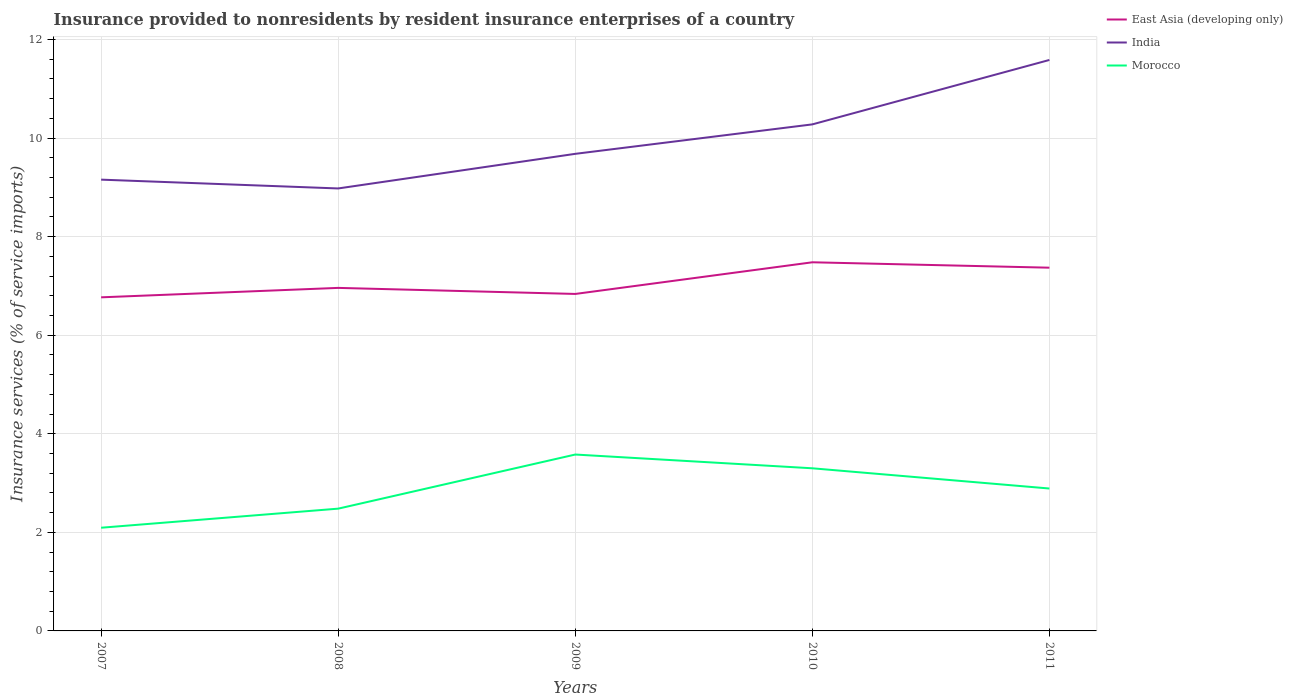Does the line corresponding to India intersect with the line corresponding to East Asia (developing only)?
Make the answer very short. No. Is the number of lines equal to the number of legend labels?
Provide a short and direct response. Yes. Across all years, what is the maximum insurance provided to nonresidents in India?
Give a very brief answer. 8.98. What is the total insurance provided to nonresidents in India in the graph?
Ensure brevity in your answer.  -1.3. What is the difference between the highest and the second highest insurance provided to nonresidents in East Asia (developing only)?
Your answer should be compact. 0.71. How many lines are there?
Provide a short and direct response. 3. What is the difference between two consecutive major ticks on the Y-axis?
Provide a succinct answer. 2. Does the graph contain any zero values?
Offer a terse response. No. Does the graph contain grids?
Make the answer very short. Yes. Where does the legend appear in the graph?
Ensure brevity in your answer.  Top right. How many legend labels are there?
Provide a succinct answer. 3. What is the title of the graph?
Make the answer very short. Insurance provided to nonresidents by resident insurance enterprises of a country. What is the label or title of the Y-axis?
Ensure brevity in your answer.  Insurance services (% of service imports). What is the Insurance services (% of service imports) of East Asia (developing only) in 2007?
Offer a very short reply. 6.77. What is the Insurance services (% of service imports) of India in 2007?
Make the answer very short. 9.16. What is the Insurance services (% of service imports) in Morocco in 2007?
Your response must be concise. 2.09. What is the Insurance services (% of service imports) in East Asia (developing only) in 2008?
Keep it short and to the point. 6.96. What is the Insurance services (% of service imports) in India in 2008?
Ensure brevity in your answer.  8.98. What is the Insurance services (% of service imports) of Morocco in 2008?
Offer a terse response. 2.48. What is the Insurance services (% of service imports) of East Asia (developing only) in 2009?
Provide a short and direct response. 6.84. What is the Insurance services (% of service imports) in India in 2009?
Offer a very short reply. 9.68. What is the Insurance services (% of service imports) of Morocco in 2009?
Keep it short and to the point. 3.58. What is the Insurance services (% of service imports) of East Asia (developing only) in 2010?
Keep it short and to the point. 7.48. What is the Insurance services (% of service imports) of India in 2010?
Provide a short and direct response. 10.28. What is the Insurance services (% of service imports) of Morocco in 2010?
Offer a terse response. 3.3. What is the Insurance services (% of service imports) of East Asia (developing only) in 2011?
Offer a terse response. 7.37. What is the Insurance services (% of service imports) in India in 2011?
Ensure brevity in your answer.  11.59. What is the Insurance services (% of service imports) of Morocco in 2011?
Your response must be concise. 2.89. Across all years, what is the maximum Insurance services (% of service imports) in East Asia (developing only)?
Offer a terse response. 7.48. Across all years, what is the maximum Insurance services (% of service imports) in India?
Offer a terse response. 11.59. Across all years, what is the maximum Insurance services (% of service imports) of Morocco?
Your response must be concise. 3.58. Across all years, what is the minimum Insurance services (% of service imports) of East Asia (developing only)?
Offer a terse response. 6.77. Across all years, what is the minimum Insurance services (% of service imports) of India?
Keep it short and to the point. 8.98. Across all years, what is the minimum Insurance services (% of service imports) of Morocco?
Ensure brevity in your answer.  2.09. What is the total Insurance services (% of service imports) in East Asia (developing only) in the graph?
Make the answer very short. 35.42. What is the total Insurance services (% of service imports) in India in the graph?
Your response must be concise. 49.68. What is the total Insurance services (% of service imports) in Morocco in the graph?
Provide a succinct answer. 14.34. What is the difference between the Insurance services (% of service imports) of East Asia (developing only) in 2007 and that in 2008?
Offer a very short reply. -0.19. What is the difference between the Insurance services (% of service imports) in India in 2007 and that in 2008?
Your answer should be very brief. 0.18. What is the difference between the Insurance services (% of service imports) of Morocco in 2007 and that in 2008?
Your answer should be compact. -0.39. What is the difference between the Insurance services (% of service imports) in East Asia (developing only) in 2007 and that in 2009?
Make the answer very short. -0.07. What is the difference between the Insurance services (% of service imports) of India in 2007 and that in 2009?
Provide a succinct answer. -0.52. What is the difference between the Insurance services (% of service imports) in Morocco in 2007 and that in 2009?
Your answer should be very brief. -1.49. What is the difference between the Insurance services (% of service imports) in East Asia (developing only) in 2007 and that in 2010?
Keep it short and to the point. -0.71. What is the difference between the Insurance services (% of service imports) in India in 2007 and that in 2010?
Your answer should be compact. -1.12. What is the difference between the Insurance services (% of service imports) of Morocco in 2007 and that in 2010?
Provide a short and direct response. -1.21. What is the difference between the Insurance services (% of service imports) in East Asia (developing only) in 2007 and that in 2011?
Ensure brevity in your answer.  -0.6. What is the difference between the Insurance services (% of service imports) in India in 2007 and that in 2011?
Offer a very short reply. -2.43. What is the difference between the Insurance services (% of service imports) of Morocco in 2007 and that in 2011?
Offer a terse response. -0.8. What is the difference between the Insurance services (% of service imports) in East Asia (developing only) in 2008 and that in 2009?
Ensure brevity in your answer.  0.12. What is the difference between the Insurance services (% of service imports) of India in 2008 and that in 2009?
Make the answer very short. -0.7. What is the difference between the Insurance services (% of service imports) of Morocco in 2008 and that in 2009?
Ensure brevity in your answer.  -1.1. What is the difference between the Insurance services (% of service imports) of East Asia (developing only) in 2008 and that in 2010?
Your response must be concise. -0.52. What is the difference between the Insurance services (% of service imports) in Morocco in 2008 and that in 2010?
Keep it short and to the point. -0.82. What is the difference between the Insurance services (% of service imports) of East Asia (developing only) in 2008 and that in 2011?
Provide a succinct answer. -0.41. What is the difference between the Insurance services (% of service imports) in India in 2008 and that in 2011?
Ensure brevity in your answer.  -2.61. What is the difference between the Insurance services (% of service imports) in Morocco in 2008 and that in 2011?
Your answer should be compact. -0.41. What is the difference between the Insurance services (% of service imports) in East Asia (developing only) in 2009 and that in 2010?
Make the answer very short. -0.64. What is the difference between the Insurance services (% of service imports) of India in 2009 and that in 2010?
Your answer should be compact. -0.6. What is the difference between the Insurance services (% of service imports) in Morocco in 2009 and that in 2010?
Your answer should be compact. 0.28. What is the difference between the Insurance services (% of service imports) in East Asia (developing only) in 2009 and that in 2011?
Offer a very short reply. -0.53. What is the difference between the Insurance services (% of service imports) in India in 2009 and that in 2011?
Ensure brevity in your answer.  -1.9. What is the difference between the Insurance services (% of service imports) in Morocco in 2009 and that in 2011?
Your answer should be compact. 0.69. What is the difference between the Insurance services (% of service imports) in East Asia (developing only) in 2010 and that in 2011?
Your answer should be very brief. 0.11. What is the difference between the Insurance services (% of service imports) of India in 2010 and that in 2011?
Your answer should be very brief. -1.31. What is the difference between the Insurance services (% of service imports) in Morocco in 2010 and that in 2011?
Provide a short and direct response. 0.41. What is the difference between the Insurance services (% of service imports) of East Asia (developing only) in 2007 and the Insurance services (% of service imports) of India in 2008?
Make the answer very short. -2.21. What is the difference between the Insurance services (% of service imports) in East Asia (developing only) in 2007 and the Insurance services (% of service imports) in Morocco in 2008?
Offer a very short reply. 4.29. What is the difference between the Insurance services (% of service imports) of India in 2007 and the Insurance services (% of service imports) of Morocco in 2008?
Give a very brief answer. 6.68. What is the difference between the Insurance services (% of service imports) in East Asia (developing only) in 2007 and the Insurance services (% of service imports) in India in 2009?
Offer a very short reply. -2.91. What is the difference between the Insurance services (% of service imports) of East Asia (developing only) in 2007 and the Insurance services (% of service imports) of Morocco in 2009?
Provide a short and direct response. 3.19. What is the difference between the Insurance services (% of service imports) in India in 2007 and the Insurance services (% of service imports) in Morocco in 2009?
Make the answer very short. 5.58. What is the difference between the Insurance services (% of service imports) of East Asia (developing only) in 2007 and the Insurance services (% of service imports) of India in 2010?
Keep it short and to the point. -3.51. What is the difference between the Insurance services (% of service imports) in East Asia (developing only) in 2007 and the Insurance services (% of service imports) in Morocco in 2010?
Give a very brief answer. 3.47. What is the difference between the Insurance services (% of service imports) of India in 2007 and the Insurance services (% of service imports) of Morocco in 2010?
Offer a very short reply. 5.86. What is the difference between the Insurance services (% of service imports) in East Asia (developing only) in 2007 and the Insurance services (% of service imports) in India in 2011?
Offer a very short reply. -4.82. What is the difference between the Insurance services (% of service imports) of East Asia (developing only) in 2007 and the Insurance services (% of service imports) of Morocco in 2011?
Offer a terse response. 3.88. What is the difference between the Insurance services (% of service imports) in India in 2007 and the Insurance services (% of service imports) in Morocco in 2011?
Offer a terse response. 6.27. What is the difference between the Insurance services (% of service imports) in East Asia (developing only) in 2008 and the Insurance services (% of service imports) in India in 2009?
Ensure brevity in your answer.  -2.72. What is the difference between the Insurance services (% of service imports) in East Asia (developing only) in 2008 and the Insurance services (% of service imports) in Morocco in 2009?
Provide a succinct answer. 3.38. What is the difference between the Insurance services (% of service imports) in India in 2008 and the Insurance services (% of service imports) in Morocco in 2009?
Offer a very short reply. 5.4. What is the difference between the Insurance services (% of service imports) of East Asia (developing only) in 2008 and the Insurance services (% of service imports) of India in 2010?
Offer a terse response. -3.32. What is the difference between the Insurance services (% of service imports) of East Asia (developing only) in 2008 and the Insurance services (% of service imports) of Morocco in 2010?
Offer a very short reply. 3.66. What is the difference between the Insurance services (% of service imports) in India in 2008 and the Insurance services (% of service imports) in Morocco in 2010?
Ensure brevity in your answer.  5.68. What is the difference between the Insurance services (% of service imports) in East Asia (developing only) in 2008 and the Insurance services (% of service imports) in India in 2011?
Offer a very short reply. -4.62. What is the difference between the Insurance services (% of service imports) of East Asia (developing only) in 2008 and the Insurance services (% of service imports) of Morocco in 2011?
Provide a short and direct response. 4.07. What is the difference between the Insurance services (% of service imports) of India in 2008 and the Insurance services (% of service imports) of Morocco in 2011?
Your answer should be very brief. 6.09. What is the difference between the Insurance services (% of service imports) in East Asia (developing only) in 2009 and the Insurance services (% of service imports) in India in 2010?
Your answer should be compact. -3.44. What is the difference between the Insurance services (% of service imports) in East Asia (developing only) in 2009 and the Insurance services (% of service imports) in Morocco in 2010?
Your response must be concise. 3.54. What is the difference between the Insurance services (% of service imports) of India in 2009 and the Insurance services (% of service imports) of Morocco in 2010?
Your answer should be very brief. 6.38. What is the difference between the Insurance services (% of service imports) in East Asia (developing only) in 2009 and the Insurance services (% of service imports) in India in 2011?
Your answer should be very brief. -4.75. What is the difference between the Insurance services (% of service imports) of East Asia (developing only) in 2009 and the Insurance services (% of service imports) of Morocco in 2011?
Keep it short and to the point. 3.95. What is the difference between the Insurance services (% of service imports) of India in 2009 and the Insurance services (% of service imports) of Morocco in 2011?
Provide a short and direct response. 6.79. What is the difference between the Insurance services (% of service imports) in East Asia (developing only) in 2010 and the Insurance services (% of service imports) in India in 2011?
Offer a terse response. -4.11. What is the difference between the Insurance services (% of service imports) of East Asia (developing only) in 2010 and the Insurance services (% of service imports) of Morocco in 2011?
Your response must be concise. 4.59. What is the difference between the Insurance services (% of service imports) of India in 2010 and the Insurance services (% of service imports) of Morocco in 2011?
Offer a terse response. 7.39. What is the average Insurance services (% of service imports) in East Asia (developing only) per year?
Make the answer very short. 7.08. What is the average Insurance services (% of service imports) of India per year?
Offer a very short reply. 9.94. What is the average Insurance services (% of service imports) of Morocco per year?
Your answer should be very brief. 2.87. In the year 2007, what is the difference between the Insurance services (% of service imports) in East Asia (developing only) and Insurance services (% of service imports) in India?
Offer a very short reply. -2.39. In the year 2007, what is the difference between the Insurance services (% of service imports) in East Asia (developing only) and Insurance services (% of service imports) in Morocco?
Your answer should be very brief. 4.67. In the year 2007, what is the difference between the Insurance services (% of service imports) in India and Insurance services (% of service imports) in Morocco?
Give a very brief answer. 7.06. In the year 2008, what is the difference between the Insurance services (% of service imports) of East Asia (developing only) and Insurance services (% of service imports) of India?
Make the answer very short. -2.02. In the year 2008, what is the difference between the Insurance services (% of service imports) in East Asia (developing only) and Insurance services (% of service imports) in Morocco?
Provide a succinct answer. 4.48. In the year 2008, what is the difference between the Insurance services (% of service imports) of India and Insurance services (% of service imports) of Morocco?
Ensure brevity in your answer.  6.5. In the year 2009, what is the difference between the Insurance services (% of service imports) of East Asia (developing only) and Insurance services (% of service imports) of India?
Provide a succinct answer. -2.84. In the year 2009, what is the difference between the Insurance services (% of service imports) in East Asia (developing only) and Insurance services (% of service imports) in Morocco?
Provide a succinct answer. 3.26. In the year 2009, what is the difference between the Insurance services (% of service imports) of India and Insurance services (% of service imports) of Morocco?
Your answer should be compact. 6.1. In the year 2010, what is the difference between the Insurance services (% of service imports) in East Asia (developing only) and Insurance services (% of service imports) in India?
Your answer should be compact. -2.8. In the year 2010, what is the difference between the Insurance services (% of service imports) of East Asia (developing only) and Insurance services (% of service imports) of Morocco?
Offer a very short reply. 4.18. In the year 2010, what is the difference between the Insurance services (% of service imports) in India and Insurance services (% of service imports) in Morocco?
Offer a terse response. 6.98. In the year 2011, what is the difference between the Insurance services (% of service imports) of East Asia (developing only) and Insurance services (% of service imports) of India?
Keep it short and to the point. -4.21. In the year 2011, what is the difference between the Insurance services (% of service imports) in East Asia (developing only) and Insurance services (% of service imports) in Morocco?
Your answer should be very brief. 4.48. In the year 2011, what is the difference between the Insurance services (% of service imports) of India and Insurance services (% of service imports) of Morocco?
Keep it short and to the point. 8.7. What is the ratio of the Insurance services (% of service imports) of East Asia (developing only) in 2007 to that in 2008?
Keep it short and to the point. 0.97. What is the ratio of the Insurance services (% of service imports) in India in 2007 to that in 2008?
Your response must be concise. 1.02. What is the ratio of the Insurance services (% of service imports) in Morocco in 2007 to that in 2008?
Your answer should be very brief. 0.84. What is the ratio of the Insurance services (% of service imports) in East Asia (developing only) in 2007 to that in 2009?
Provide a succinct answer. 0.99. What is the ratio of the Insurance services (% of service imports) in India in 2007 to that in 2009?
Your response must be concise. 0.95. What is the ratio of the Insurance services (% of service imports) of Morocco in 2007 to that in 2009?
Make the answer very short. 0.59. What is the ratio of the Insurance services (% of service imports) of East Asia (developing only) in 2007 to that in 2010?
Provide a succinct answer. 0.9. What is the ratio of the Insurance services (% of service imports) in India in 2007 to that in 2010?
Provide a short and direct response. 0.89. What is the ratio of the Insurance services (% of service imports) in Morocco in 2007 to that in 2010?
Make the answer very short. 0.63. What is the ratio of the Insurance services (% of service imports) of East Asia (developing only) in 2007 to that in 2011?
Provide a short and direct response. 0.92. What is the ratio of the Insurance services (% of service imports) of India in 2007 to that in 2011?
Make the answer very short. 0.79. What is the ratio of the Insurance services (% of service imports) of Morocco in 2007 to that in 2011?
Offer a terse response. 0.72. What is the ratio of the Insurance services (% of service imports) in India in 2008 to that in 2009?
Provide a succinct answer. 0.93. What is the ratio of the Insurance services (% of service imports) of Morocco in 2008 to that in 2009?
Ensure brevity in your answer.  0.69. What is the ratio of the Insurance services (% of service imports) of East Asia (developing only) in 2008 to that in 2010?
Offer a very short reply. 0.93. What is the ratio of the Insurance services (% of service imports) of India in 2008 to that in 2010?
Offer a terse response. 0.87. What is the ratio of the Insurance services (% of service imports) in Morocco in 2008 to that in 2010?
Keep it short and to the point. 0.75. What is the ratio of the Insurance services (% of service imports) in India in 2008 to that in 2011?
Provide a short and direct response. 0.78. What is the ratio of the Insurance services (% of service imports) of Morocco in 2008 to that in 2011?
Your answer should be compact. 0.86. What is the ratio of the Insurance services (% of service imports) of East Asia (developing only) in 2009 to that in 2010?
Keep it short and to the point. 0.91. What is the ratio of the Insurance services (% of service imports) in India in 2009 to that in 2010?
Offer a terse response. 0.94. What is the ratio of the Insurance services (% of service imports) in Morocco in 2009 to that in 2010?
Provide a succinct answer. 1.08. What is the ratio of the Insurance services (% of service imports) of East Asia (developing only) in 2009 to that in 2011?
Give a very brief answer. 0.93. What is the ratio of the Insurance services (% of service imports) in India in 2009 to that in 2011?
Keep it short and to the point. 0.84. What is the ratio of the Insurance services (% of service imports) of Morocco in 2009 to that in 2011?
Your answer should be compact. 1.24. What is the ratio of the Insurance services (% of service imports) of East Asia (developing only) in 2010 to that in 2011?
Your response must be concise. 1.01. What is the ratio of the Insurance services (% of service imports) of India in 2010 to that in 2011?
Your answer should be very brief. 0.89. What is the ratio of the Insurance services (% of service imports) in Morocco in 2010 to that in 2011?
Offer a terse response. 1.14. What is the difference between the highest and the second highest Insurance services (% of service imports) in East Asia (developing only)?
Your answer should be very brief. 0.11. What is the difference between the highest and the second highest Insurance services (% of service imports) in India?
Offer a terse response. 1.31. What is the difference between the highest and the second highest Insurance services (% of service imports) in Morocco?
Your answer should be compact. 0.28. What is the difference between the highest and the lowest Insurance services (% of service imports) in East Asia (developing only)?
Ensure brevity in your answer.  0.71. What is the difference between the highest and the lowest Insurance services (% of service imports) of India?
Offer a terse response. 2.61. What is the difference between the highest and the lowest Insurance services (% of service imports) of Morocco?
Provide a short and direct response. 1.49. 